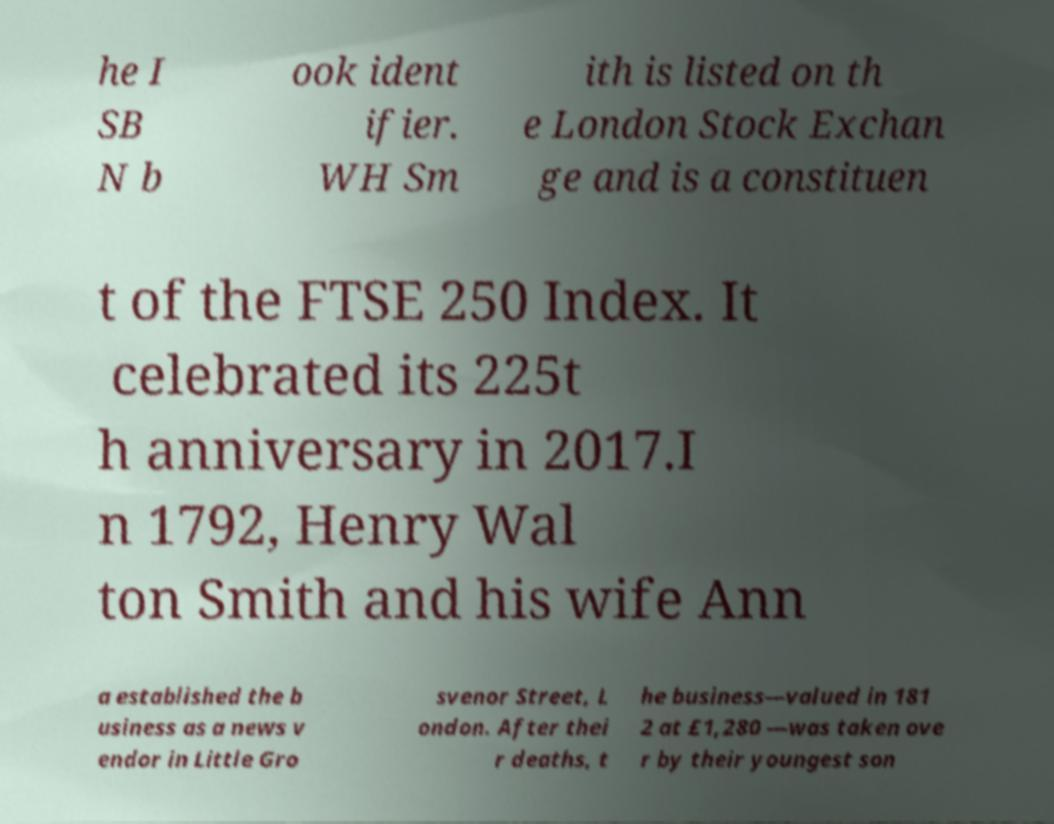What messages or text are displayed in this image? I need them in a readable, typed format. he I SB N b ook ident ifier. WH Sm ith is listed on th e London Stock Exchan ge and is a constituen t of the FTSE 250 Index. It celebrated its 225t h anniversary in 2017.I n 1792, Henry Wal ton Smith and his wife Ann a established the b usiness as a news v endor in Little Gro svenor Street, L ondon. After thei r deaths, t he business—valued in 181 2 at £1,280 —was taken ove r by their youngest son 